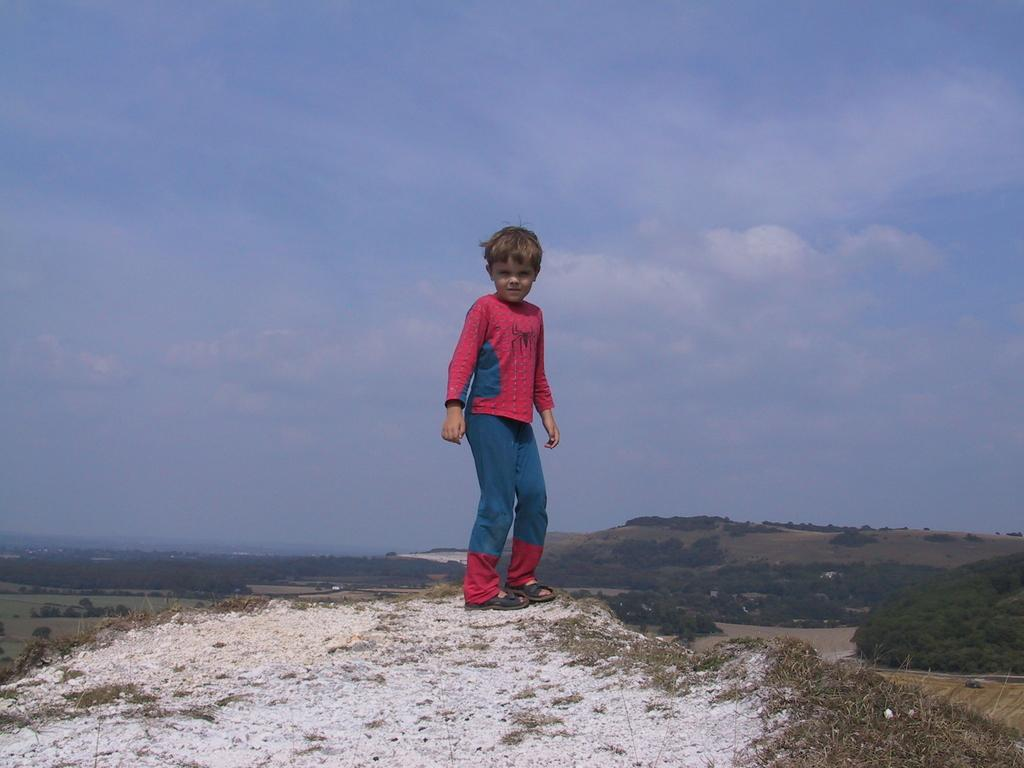What is the main subject of the image? There is a boy standing in the image. Where is the boy standing? The boy is standing on a small hill. What type of vegetation can be seen in the image? Grass and trees are visible in the image. What other geographical features are present in the image? There are hills in the image. What part of the natural environment is visible in the image? The ground and the sky are visible in the image. What is the condition of the sky in the image? Clouds are present in the sky. What type of sign can be seen in the image? There is no sign present in the image; it features a boy standing on a hill with grass, trees, and clouds in the sky. What is the boy doing to improve his hearing in the image? There is no indication in the image that the boy is trying to improve his hearing or that hearing is relevant to the image. 